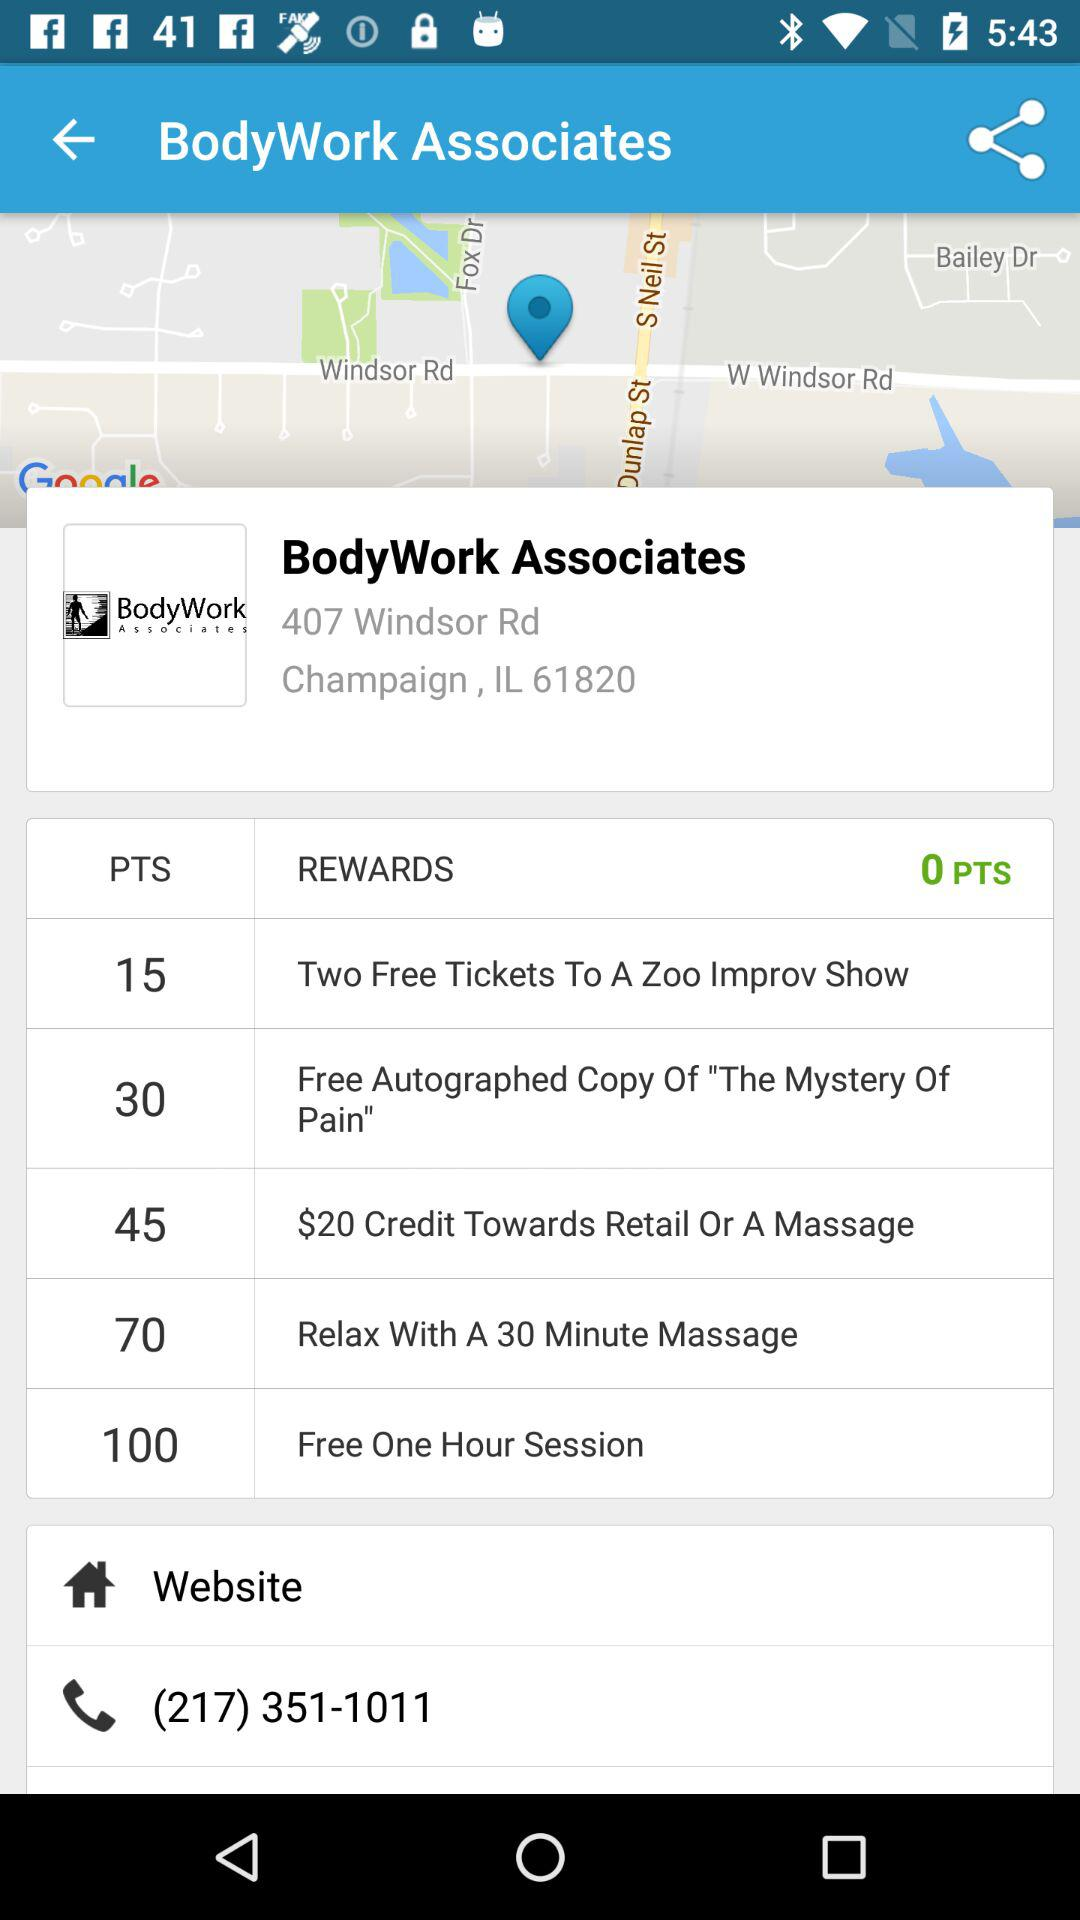What is the website URL?
When the provided information is insufficient, respond with <no answer>. <no answer> 